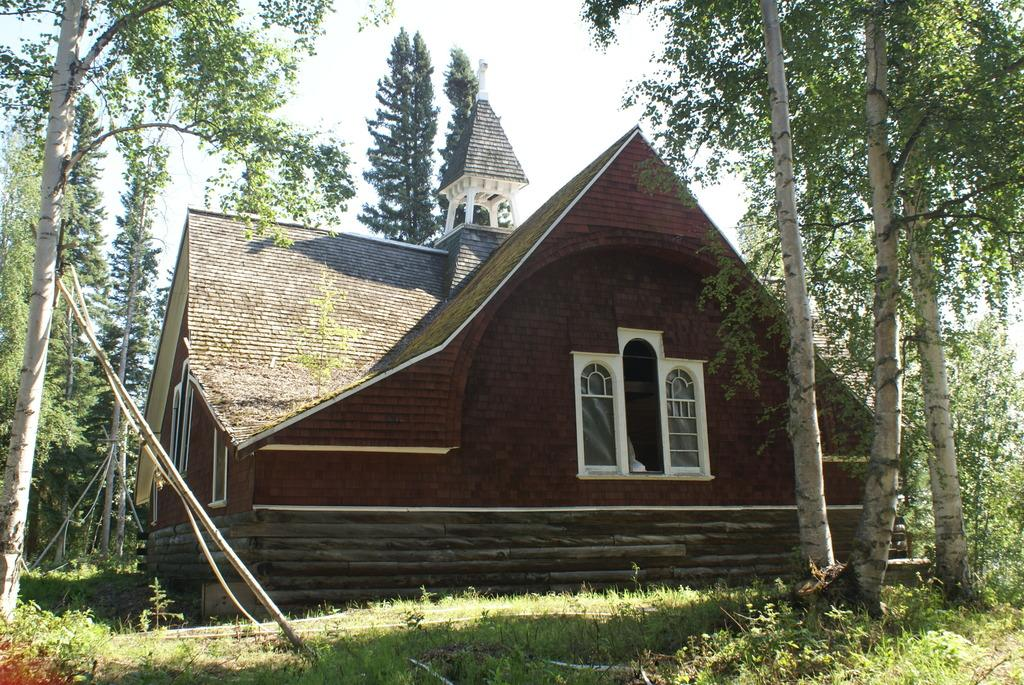What is the main structure in the center of the image? There is a house in the center of the image. What type of vegetation can be seen on both sides of the image? There are trees on the right side and the left side of the image. What type of ground is visible at the bottom of the image? There is grass at the bottom of the image. What is visible in the background of the image? The sky is visible at the top of the image. What type of toy can be seen on the dinner table in the image? There is no toy or dinner table present in the image. 